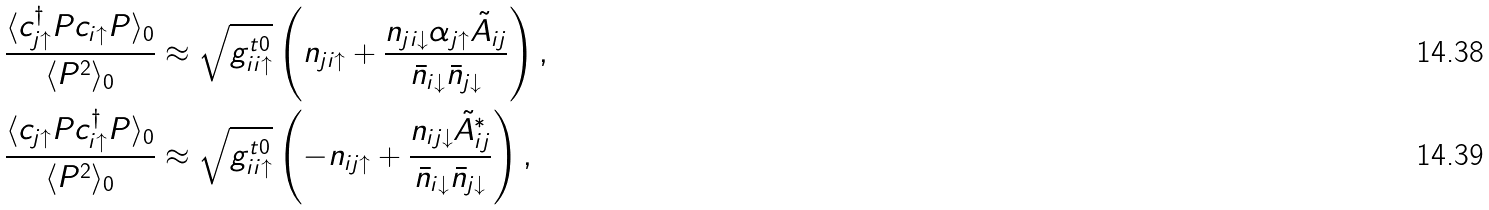Convert formula to latex. <formula><loc_0><loc_0><loc_500><loc_500>\frac { \langle c _ { j \uparrow } ^ { \dagger } P c _ { i \uparrow } P \rangle _ { 0 } } { \langle P ^ { 2 } \rangle _ { 0 } } & \approx \sqrt { g _ { i i \uparrow } ^ { t 0 } } \left ( n _ { j i \uparrow } + \frac { n _ { j i \downarrow } \alpha _ { j \uparrow } \tilde { A } _ { i j } } { \bar { n } _ { i \downarrow } \bar { n } _ { j \downarrow } } \right ) , \\ \frac { \langle c _ { j \uparrow } P c _ { i \uparrow } ^ { \dagger } P \rangle _ { 0 } } { \langle P ^ { 2 } \rangle _ { 0 } } & \approx \sqrt { g _ { i i \uparrow } ^ { t 0 } } \left ( - n _ { i j \uparrow } + \frac { n _ { i j \downarrow } \tilde { A } _ { i j } ^ { * } } { \bar { n } _ { i \downarrow } \bar { n } _ { j \downarrow } } \right ) ,</formula> 